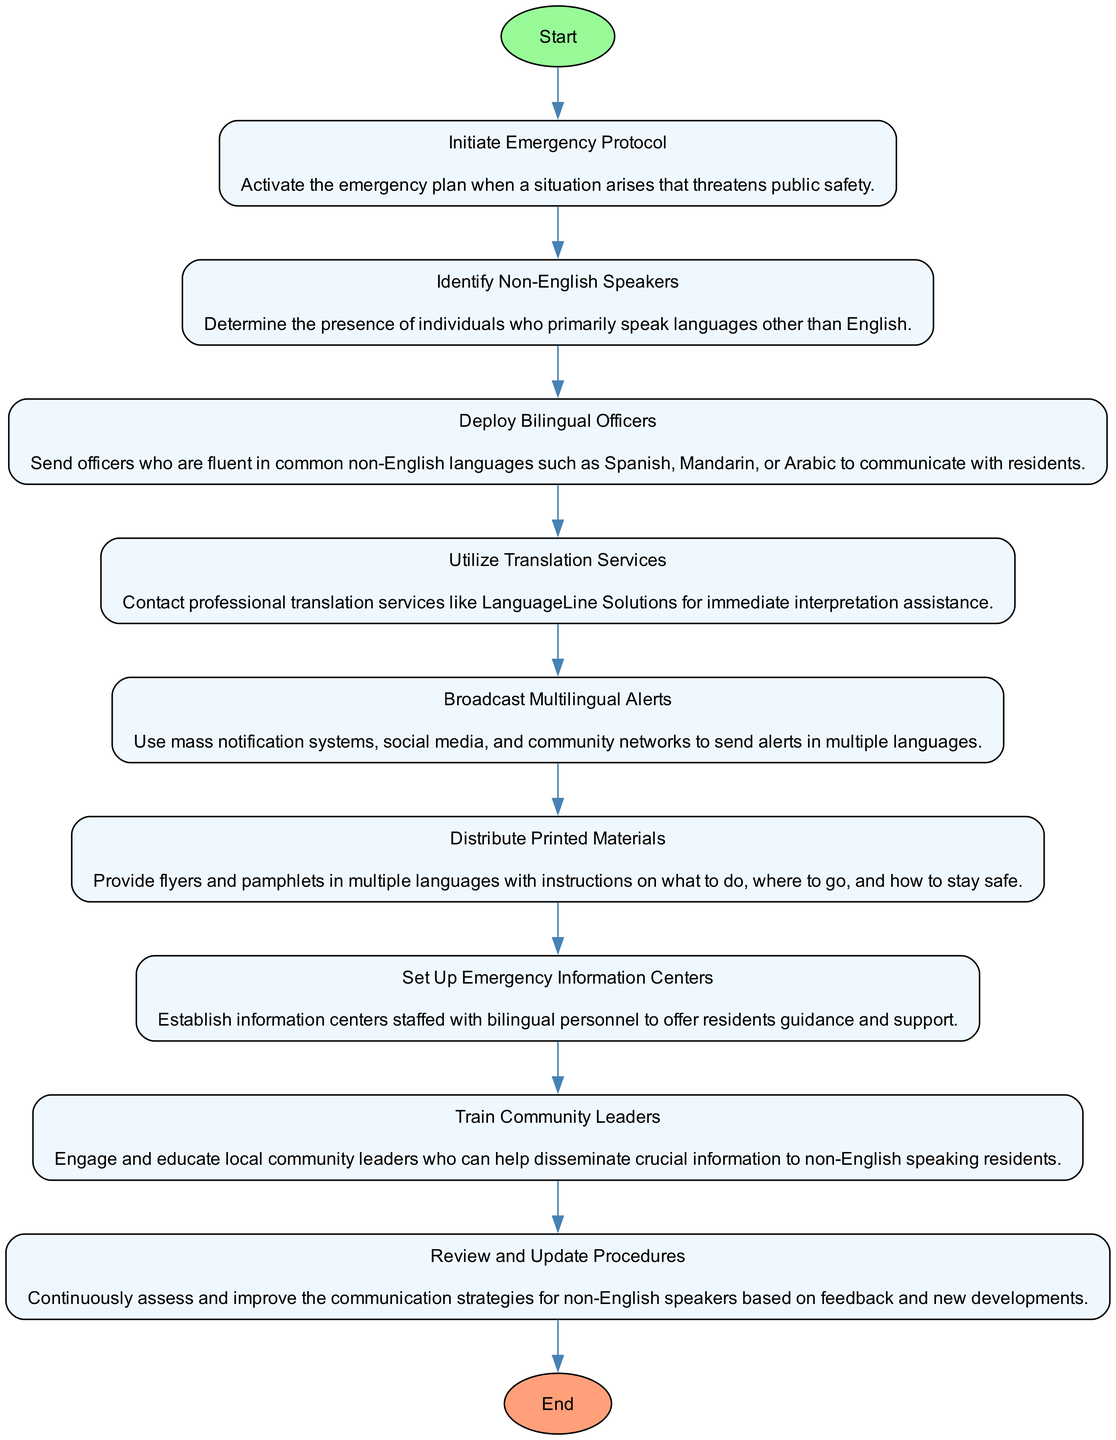What is the first step in the process? The first step is to 'Initiate Emergency Protocol', as indicated at the top of the diagram, which is the starting point.
Answer: Initiate Emergency Protocol How many total steps are in the diagram? By counting the nodes in the diagram, there are eight steps listed in the process.
Answer: Eight What step follows 'Identify Non-English Speakers'? The step that follows 'Identify Non-English Speakers' is 'Deploy Bilingual Officers,' which is the direct connection in the flow.
Answer: Deploy Bilingual Officers Which service is suggested for immediate interpretation assistance? The diagram suggests using 'Translation Services' for immediate assistance, specifically mentioning contacting professional translation services.
Answer: Translation Services What step is related to ensuring communication with community leaders? The step related to community leaders is 'Train Community Leaders,' emphasizing the importance of educating local leaders for effective communication.
Answer: Train Community Leaders How many end nodes are in the diagram? There is only one end node in the diagram, which is labeled 'End' and signifies the conclusion of the process.
Answer: One What step includes distributing informational flyers? The step that includes distributing flyers is 'Distribute Printed Materials,' which focuses on providing non-English speakers with necessary instructions.
Answer: Distribute Printed Materials What is emphasized as part of ongoing strategy improvement? The step 'Review and Update Procedures' emphasizes the need for continuous assessment and improvement of the communication strategies.
Answer: Review and Update Procedures What is the purpose of 'Set Up Emergency Information Centers'? The purpose is to offer guidance and support to residents by ensuring that information centers are staffed with bilingual personnel.
Answer: Offer guidance and support 